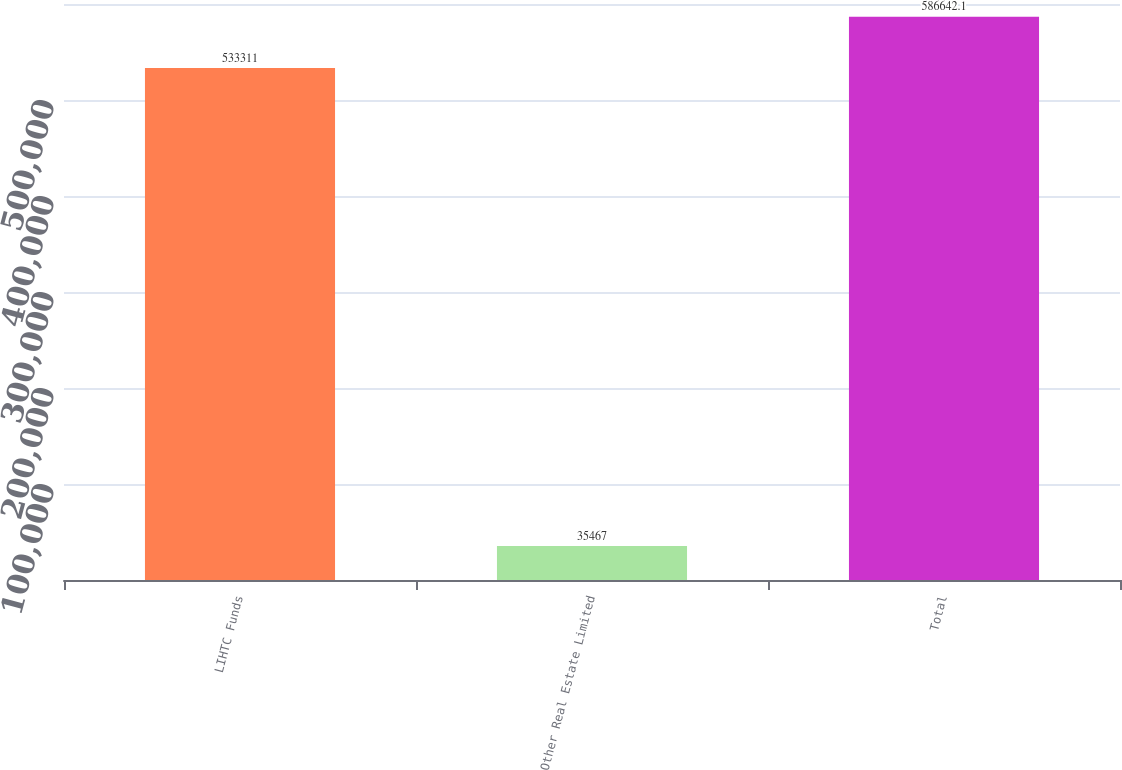<chart> <loc_0><loc_0><loc_500><loc_500><bar_chart><fcel>LIHTC Funds<fcel>Other Real Estate Limited<fcel>Total<nl><fcel>533311<fcel>35467<fcel>586642<nl></chart> 